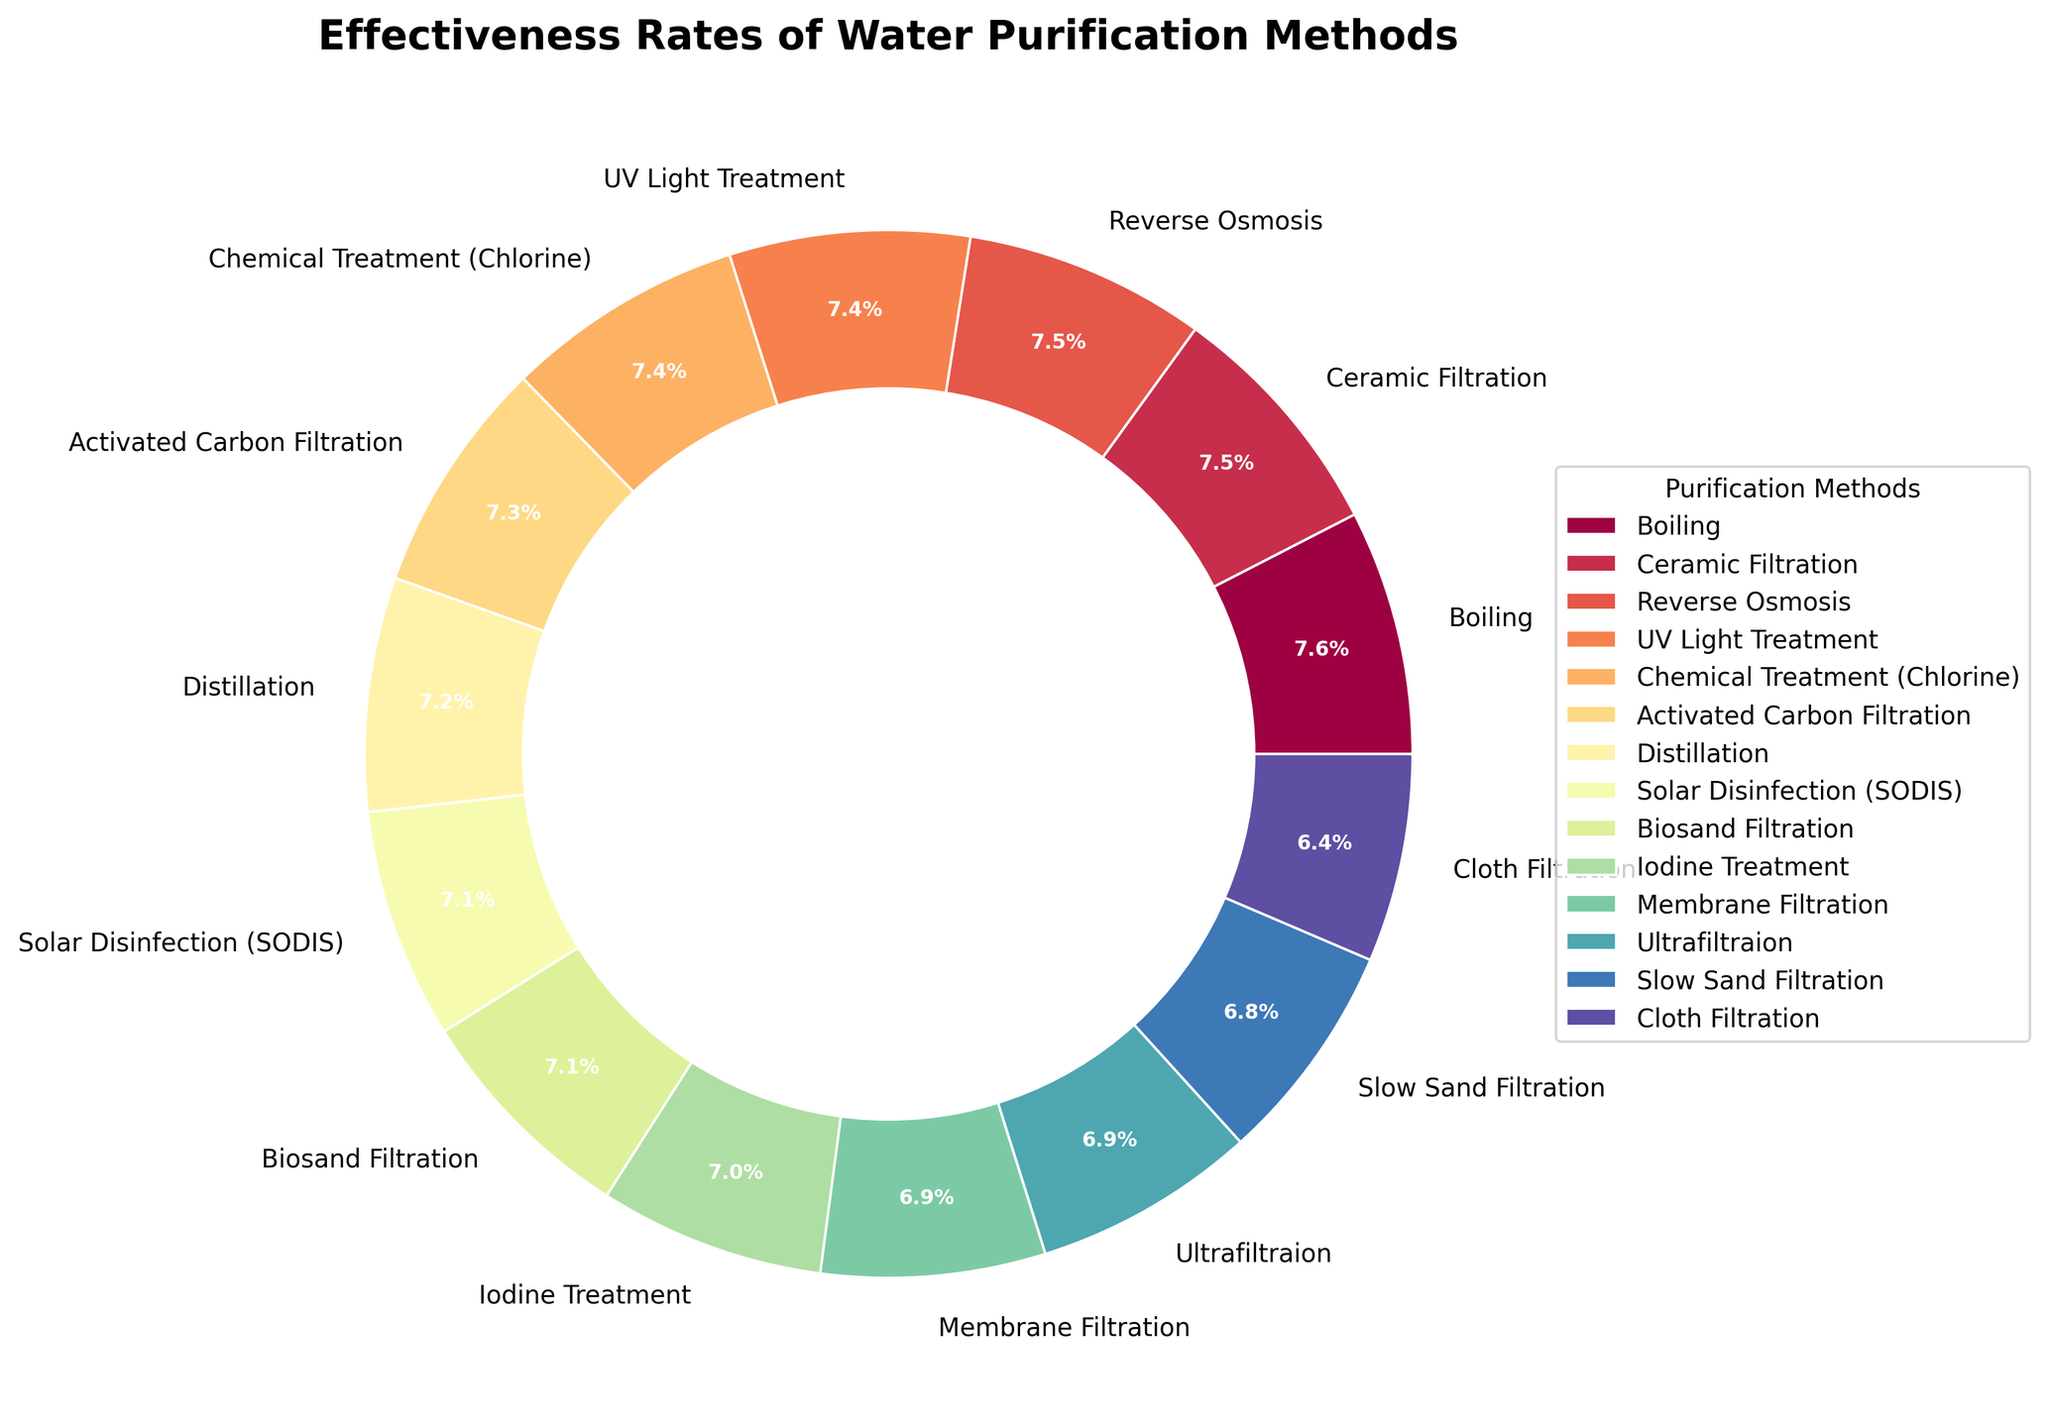Which method has the highest effectiveness rate? Identify the slice of the pie chart with the largest percentage label.
Answer: Boiling Which two methods have effectiveness rates closest to each other? Look at the pie chart for pairs of slices with percentages close to each other. Compare the percentages: Reverse Osmosis (98.5%) and UV Light Treatment (98.0%) are the closest.
Answer: Reverse Osmosis and UV Light Treatment How much more effective is Chemical Treatment (Chlorine) compared to Cloth Filtration? Find the percentage for Chemical Treatment (Chlorine) and Cloth Filtration, then subtract the latter from the former: 97.5% - 85.0% = 12.5%.
Answer: 12.5% Which methods have effectiveness rates above 95%? Identify slices in the pie chart labeled with percentages greater than 95%: Boiling, Ceramic Filtration, Reverse Osmosis, and UV Light Treatment.
Answer: Boiling, Ceramic Filtration, Reverse Osmosis, UV Light Treatment What is the visual effect of adding a circle at the center of the pie chart? Observe the visual characteristic of the pie chart: The circle in the center creates a donut chart effect, which can make it visually easier to distinguish slices.
Answer: Donut chart effect Among Iodine Treatment, Membrane Filtration, and Ultrafiltration, which is the least effective? Compare the effectiveness rates of these three methods; the lowest percentage is the least effective: Iodine Treatment (92.0%).
Answer: Iodine Treatment What is the average effectiveness rate of Ceramic Filtration and Solar Disinfection (SODIS)? Sum the effectiveness rates of Ceramic Filtration (99.0%) and SODIS (94.0%), then divide by 2: (99.0 + 94.0) / 2 = 96.5%.
Answer: 96.5% Which method's effectiveness rate is closest to 97%? Find the slice labeled closest to 97%; Chemical Treatment (Chlorine) has a rate of 97.5%, which is nearest to 97%.
Answer: Chemical Treatment (Chlorine) How many methods have an effectiveness rate greater than 90% but less than 95%? Count the slices with percentages in this range: Distillation (95.5%), Solar Disinfection (94.0%), and Biosand Filtration (93.5%).
Answer: 3 